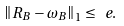Convert formula to latex. <formula><loc_0><loc_0><loc_500><loc_500>\left \| R _ { B } - \omega _ { B } \right \| _ { 1 } \leq \ e .</formula> 